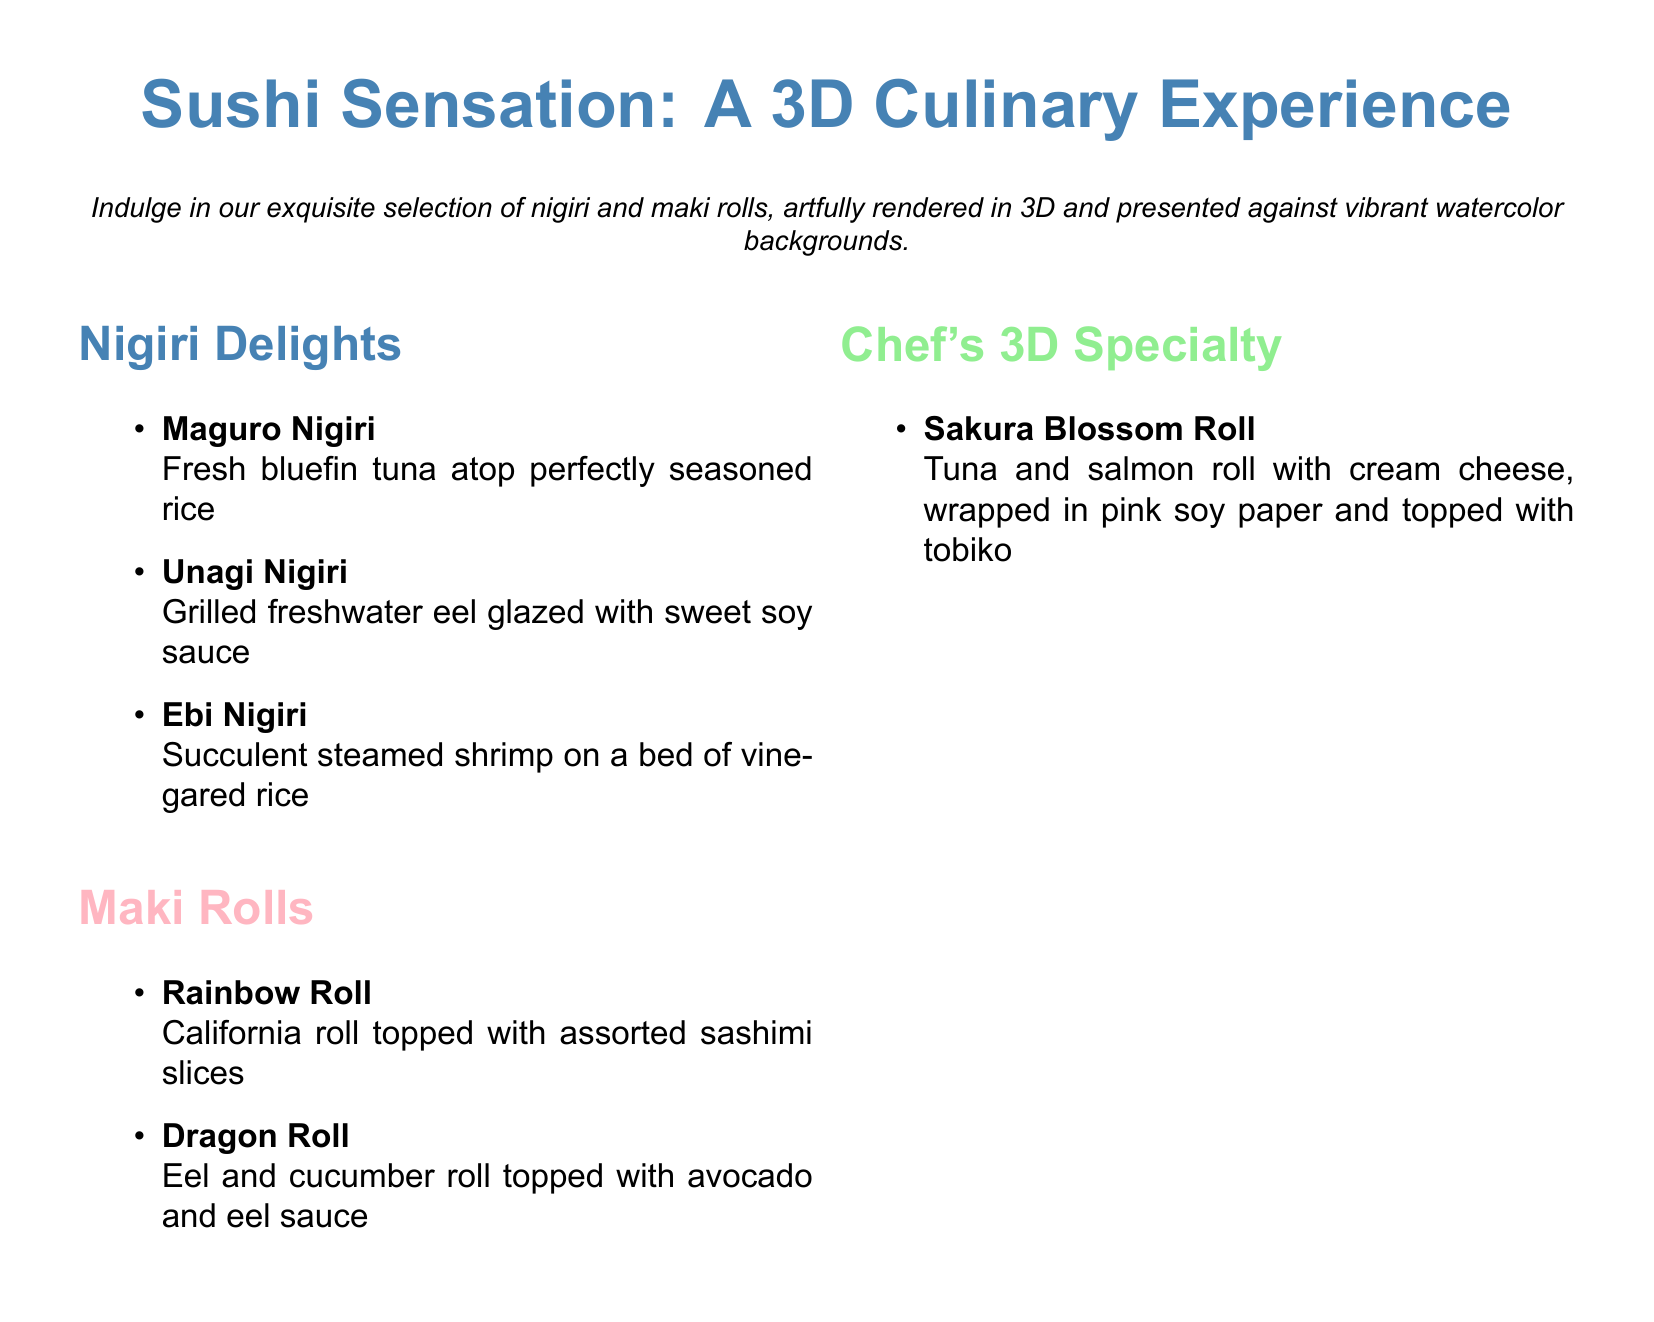What is the name of the sushi menu? The name of the sushi menu is found in the title section of the document.
Answer: Sushi Sensation: A 3D Culinary Experience What color is used for Nigiri Delights section? The color used for the Nigiri Delights section is specified in the document.
Answer: sushiBlue How many types of Nigiri are listed? The count of Nigiri types can be found by reviewing the listed items under Nigiri Delights.
Answer: 3 What is the main ingredient in the Rainbow Roll? The main ingredient of the Rainbow Roll is mentioned in the description.
Answer: California roll What unique feature does the Sakura Blossom Roll have? The unique feature of the Sakura Blossom Roll is described in its ingredients.
Answer: Pink soy paper Which roll is topped with assorted sashimi slices? The roll described as topped with assorted sashimi slices is clearly stated in the Maki Rolls section.
Answer: Rainbow Roll How is the Unagi Nigiri prepared? The preparation method of Unagi Nigiri is included in its description.
Answer: Grilled What decorative element accompanies the sushi in the document? The decorative element that accompanies the sushi is mentioned in the descriptive content.
Answer: Watercolor backgrounds 